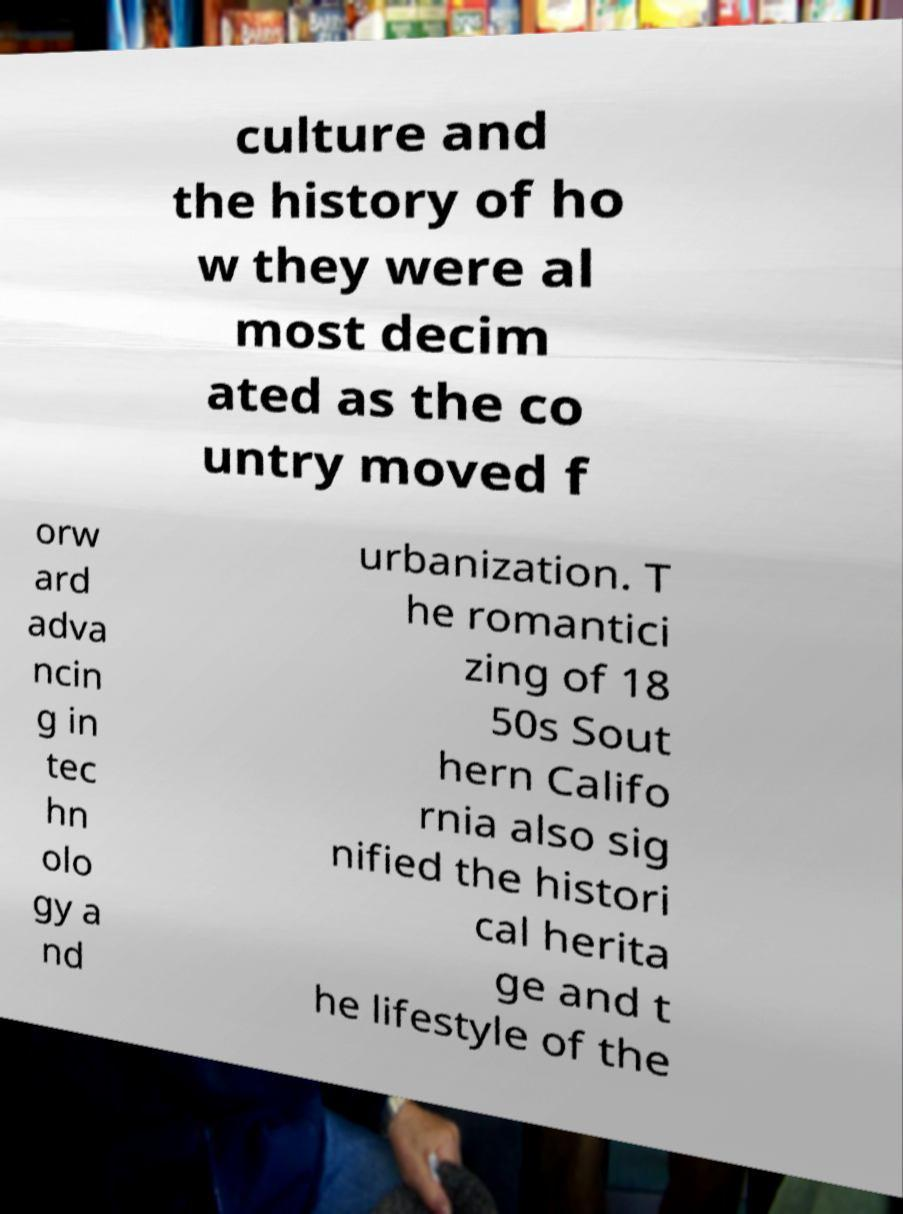Could you assist in decoding the text presented in this image and type it out clearly? culture and the history of ho w they were al most decim ated as the co untry moved f orw ard adva ncin g in tec hn olo gy a nd urbanization. T he romantici zing of 18 50s Sout hern Califo rnia also sig nified the histori cal herita ge and t he lifestyle of the 